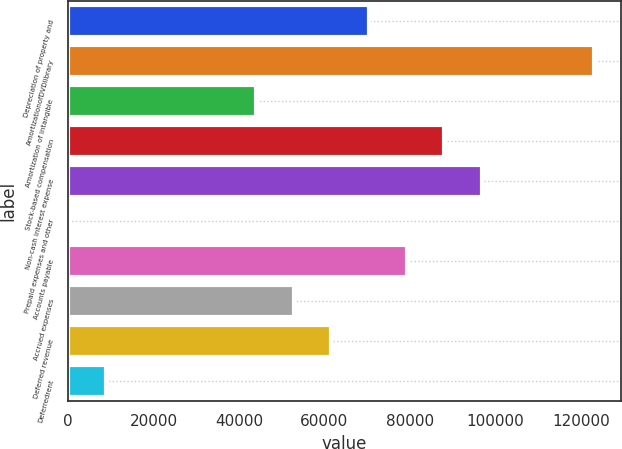Convert chart. <chart><loc_0><loc_0><loc_500><loc_500><bar_chart><fcel>Depreciation of property and<fcel>AmortizationofDVDlibrary<fcel>Amortization of intangible<fcel>Stock-based compensation<fcel>Non-cash interest expense<fcel>Prepaid expenses and other<fcel>Accounts payable<fcel>Accrued expenses<fcel>Deferred revenue<fcel>Deferredrent<nl><fcel>70424.8<fcel>123210<fcel>44032<fcel>88020<fcel>96817.6<fcel>44<fcel>79222.4<fcel>52829.6<fcel>61627.2<fcel>8841.6<nl></chart> 